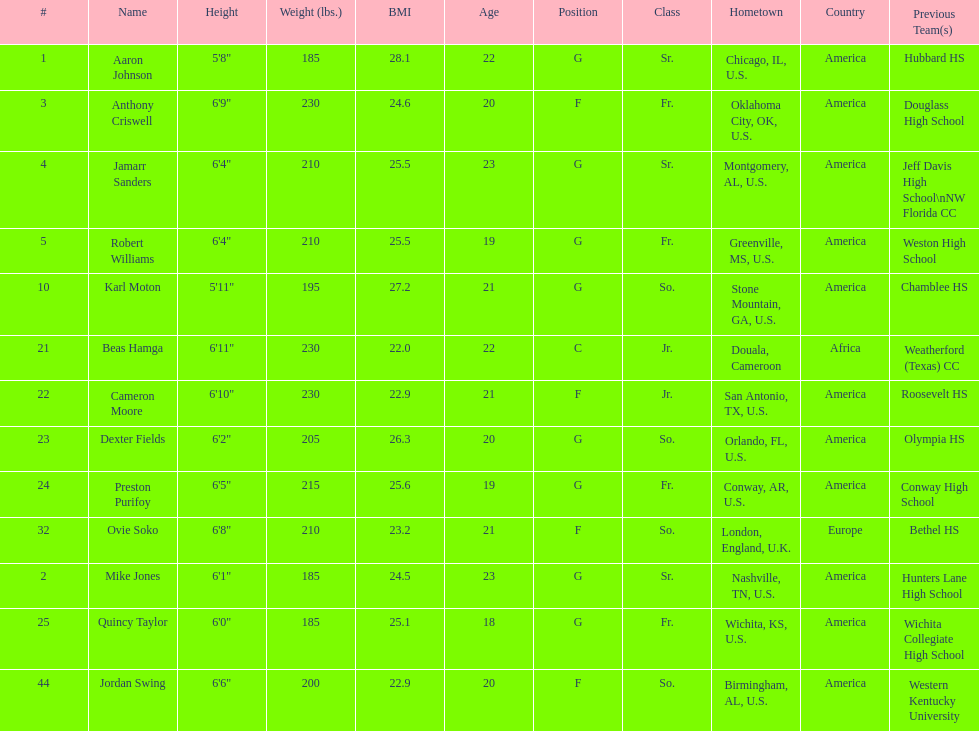Who weighs more, dexter fields or ovie soko? Ovie Soko. Give me the full table as a dictionary. {'header': ['#', 'Name', 'Height', 'Weight (lbs.)', 'BMI', 'Age', 'Position', 'Class', 'Hometown', 'Country', 'Previous Team(s)'], 'rows': [['1', 'Aaron Johnson', '5\'8"', '185', '28.1', '22', 'G', 'Sr.', 'Chicago, IL, U.S.', 'America', 'Hubbard HS'], ['3', 'Anthony Criswell', '6\'9"', '230', '24.6', '20', 'F', 'Fr.', 'Oklahoma City, OK, U.S.', 'America', 'Douglass High School'], ['4', 'Jamarr Sanders', '6\'4"', '210', '25.5', '23', 'G', 'Sr.', 'Montgomery, AL, U.S.', 'America', 'Jeff Davis High School\\nNW Florida CC'], ['5', 'Robert Williams', '6\'4"', '210', '25.5', '19', 'G', 'Fr.', 'Greenville, MS, U.S.', 'America', 'Weston High School'], ['10', 'Karl Moton', '5\'11"', '195', '27.2', '21', 'G', 'So.', 'Stone Mountain, GA, U.S.', 'America', 'Chamblee HS'], ['21', 'Beas Hamga', '6\'11"', '230', '22.0', '22', 'C', 'Jr.', 'Douala, Cameroon', 'Africa', 'Weatherford (Texas) CC'], ['22', 'Cameron Moore', '6\'10"', '230', '22.9', '21', 'F', 'Jr.', 'San Antonio, TX, U.S.', 'America', 'Roosevelt HS'], ['23', 'Dexter Fields', '6\'2"', '205', '26.3', '20', 'G', 'So.', 'Orlando, FL, U.S.', 'America', 'Olympia HS'], ['24', 'Preston Purifoy', '6\'5"', '215', '25.6', '19', 'G', 'Fr.', 'Conway, AR, U.S.', 'America', 'Conway High School'], ['32', 'Ovie Soko', '6\'8"', '210', '23.2', '21', 'F', 'So.', 'London, England, U.K.', 'Europe', 'Bethel HS'], ['2', 'Mike Jones', '6\'1"', '185', '24.5', '23', 'G', 'Sr.', 'Nashville, TN, U.S.', 'America', 'Hunters Lane High School'], ['25', 'Quincy Taylor', '6\'0"', '185', '25.1', '18', 'G', 'Fr.', 'Wichita, KS, U.S.', 'America', 'Wichita Collegiate High School'], ['44', 'Jordan Swing', '6\'6"', '200', '22.9', '20', 'F', 'So.', 'Birmingham, AL, U.S.', 'America', 'Western Kentucky University']]} 